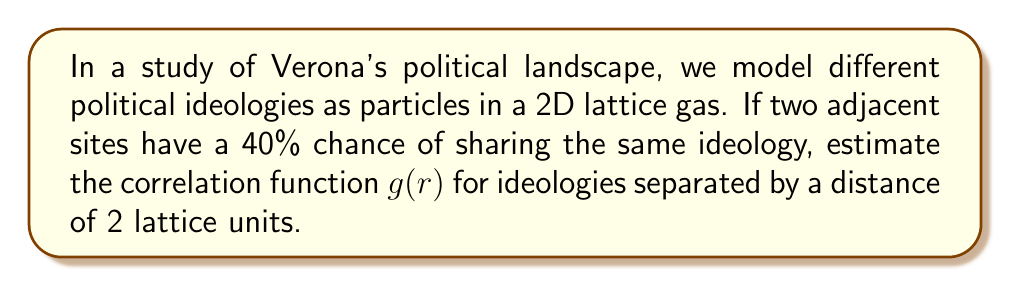Solve this math problem. To solve this problem, we'll use the lattice gas model and calculate the correlation function:

1) In a lattice gas model, the correlation function $g(r)$ is given by:

   $$g(r) = e^{-r/\xi}$$

   where $r$ is the distance and $\xi$ is the correlation length.

2) We need to find $\xi$ first. For adjacent sites (r = 1), we're given:

   $$g(1) = 0.4 = e^{-1/\xi}$$

3) Taking the natural log of both sides:

   $$\ln(0.4) = -1/\xi$$

4) Solving for $\xi$:

   $$\xi = -1/\ln(0.4) \approx 1.4427$$

5) Now we can calculate $g(r)$ for r = 2:

   $$g(2) = e^{-2/\xi} = e^{-2/1.4427} \approx 0.2466$$

6) This means that political ideologies separated by 2 lattice units have about a 24.66% chance of being the same.
Answer: $g(2) \approx 0.2466$ 